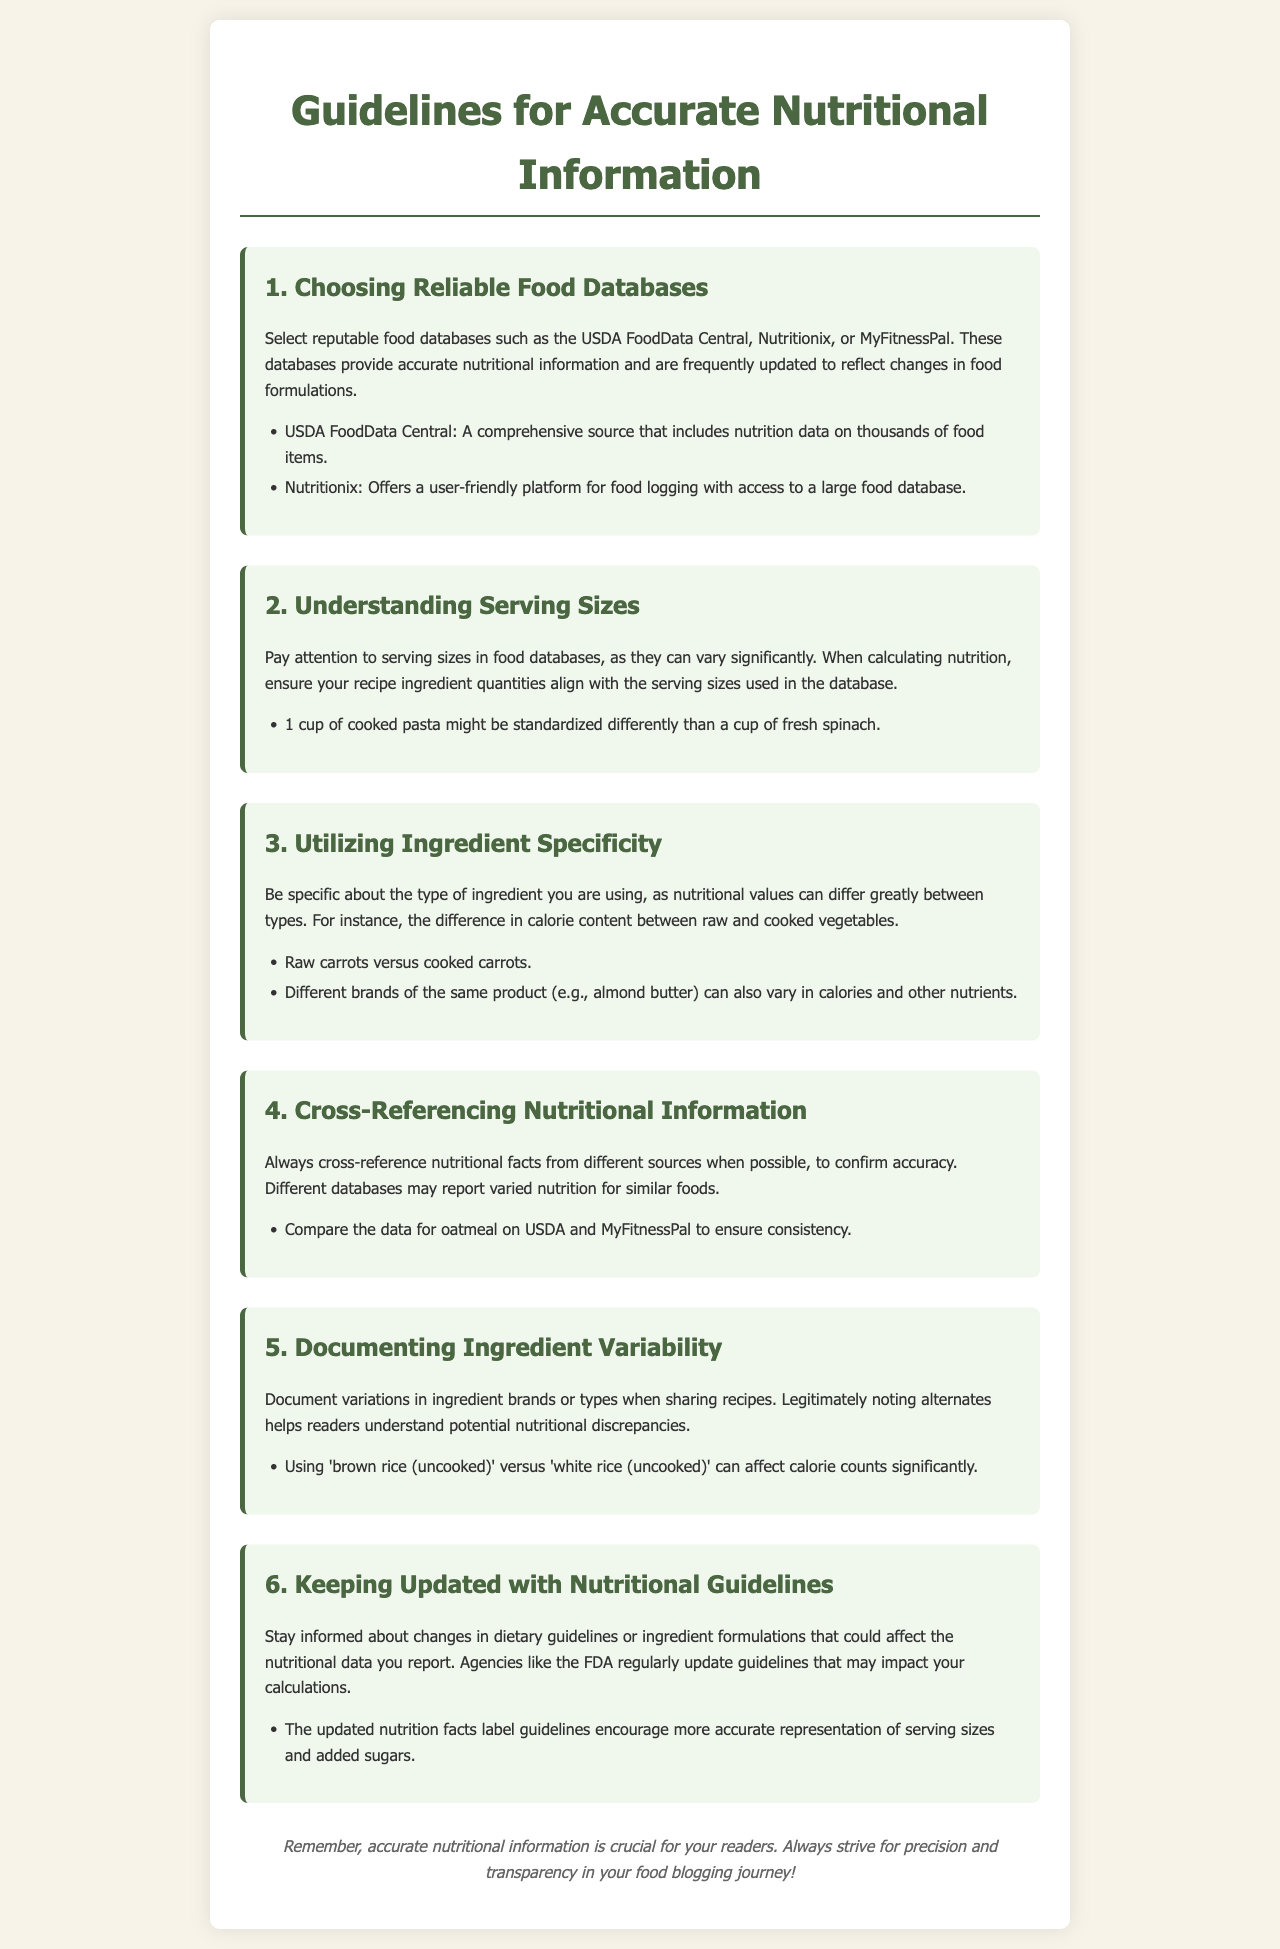What are two recommended food databases? The document lists USDA FoodData Central and Nutritionix as reputable food databases for accurate nutritional information.
Answer: USDA FoodData Central, Nutritionix What is the importance of serving sizes? The document emphasizes that serving sizes can vary significantly, which is crucial for accurate nutritional calculations.
Answer: Serving sizes can vary significantly What should you document when sharing recipes? The document suggests documenting variations in ingredient brands or types to help readers understand potential nutritional discrepancies.
Answer: Ingredient brands or types What can affect calorie counts significantly? The document states that using different types of rice, such as brown rice versus white rice, can lead to significant differences in calorie counts.
Answer: Brown rice versus white rice What does the document recommend for cross-referencing nutritional information? The document advises comparing nutritional facts from different sources, like USDA and MyFitnessPal, to confirm accuracy.
Answer: Compare USDA and MyFitnessPal How does the document suggest you stay informed? It recommends keeping updated with changes in dietary guidelines or ingredient formulations that could impact nutritional data.
Answer: Dietary guidelines or ingredient formulations What is the main purpose of these guidelines? The document highlights that the primary aim is to ensure precise and transparent nutritional information for readers.
Answer: Accurate nutritional information What type of differences can occur with ingredient specificity? The document mentions that nutritional values can differ greatly between types, as illustrated by raw versus cooked vegetables.
Answer: Raw versus cooked vegetables 